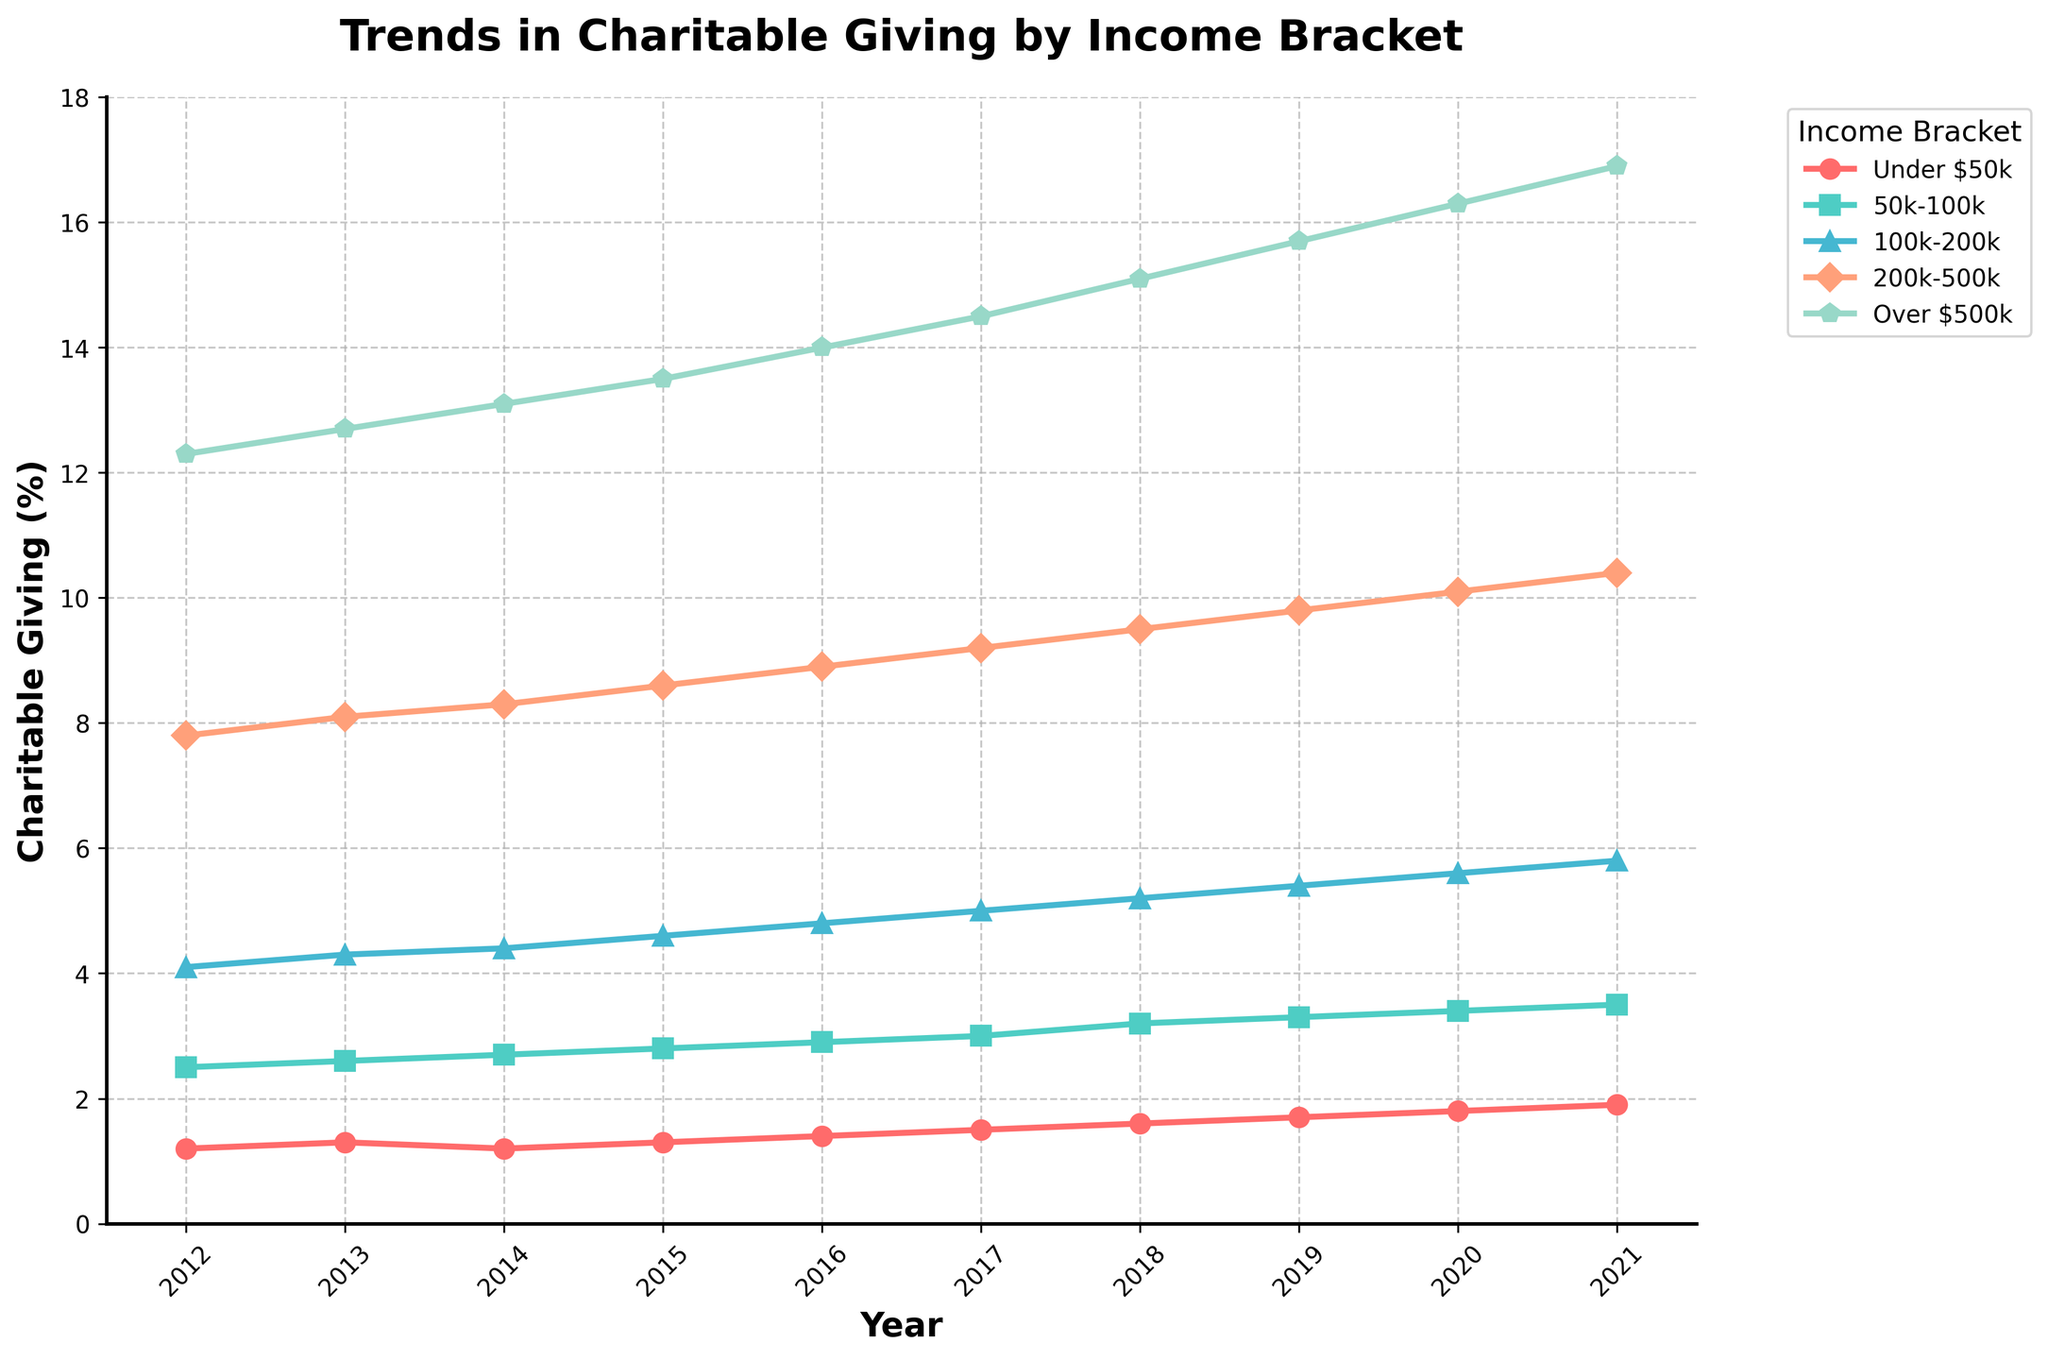Which income bracket shows the greatest increase in charitable giving over the decade? To determine the income bracket with the greatest increase, subtract the percentage in 2012 from the percentage in 2021 for each bracket. The brackets show increases of 0.7%, 1.0%, 1.7%, 2.6%, and 4.6% respectively. The "Over $500k" bracket has the greatest increase at 4.6%.
Answer: Over $500k Which year did the "50k-100k" bracket first surpass 3% in charitable giving? Locate the point where the "50k-100k" line first crosses the 3% level on the y-axis. This occurs in 2017.
Answer: 2017 Compared to 2014, how much did charitable giving in the "Under $50k" bracket change by 2021? Subtract the percentage in 2014 from the percentage in 2021 for the "Under $50k" bracket. This is 1.9% - 1.2% = 0.7%.
Answer: 0.7% Which income bracket had the smallest increase in charitable giving over the decade? Calculate the increase for each bracket from 2012 to 2021. The increases are 0.7%, 1.0%, 1.7%, 2.6%, and 4.6% respectively. The "Under $50k" bracket had the smallest increase at 0.7%.
Answer: Under $50k How does the growth trend from 2012 to 2021 for the "100k-200k" bracket compare to the "200k-500k" bracket? Examine the increase for both brackets over the period. The "100k-200k" bracket increased from 4.1% to 5.8%, an increase of 1.7%. The "200k-500k" bracket increased from 7.8% to 10.4%, an increase of 2.6%. The "200k-500k" bracket shows a larger increase.
Answer: The "200k-500k" bracket shows a larger increase Which year features the largest gap between the charitable giving of the "Under $50k" and "Over $500k" brackets? Calculate the differences between the two brackets for each year. The largest gap occurs in 2021, with a difference of 16.9% - 1.9% = 15.0%.
Answer: 2021 What is the average charitable giving percentage for the "50k-100k" bracket over the decade? Sum the percentages for the "50k-100k" bracket from 2012 to 2021 and divide by the number of years (10). This is (2.5 + 2.6 + 2.7 + 2.8 + 2.9 + 3.0 + 3.2 + 3.3 + 3.4 + 3.5) / 10 = 2.99%.
Answer: 2.99% In which year did the "100k-200k" and "200k-500k" brackets show the closest charitable giving percentages? Compare the differences in percentages between the "100k-200k" and "200k-500k" brackets for each year. The smallest difference occurs in 2012 with a difference of 7.8% - 4.1% = 3.7%.
Answer: 2012 What is the total charitable giving percentage in 2019 across all income brackets? Sum the percentages for all brackets in 2019. This is 1.7% + 3.3% + 5.4% + 9.8% + 15.7% = 35.9%.
Answer: 35.9% 